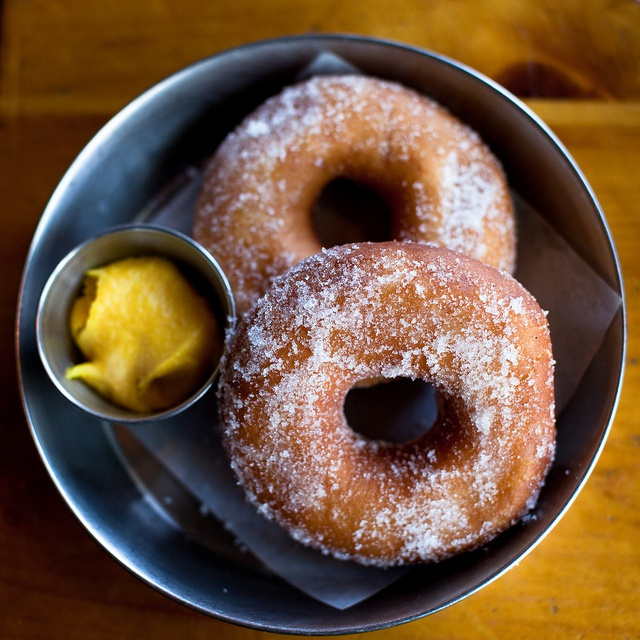Describe the objects in this image and their specific colors. I can see bowl in black, maroon, lavender, and lightpink tones, donut in black, lavender, brown, and lightpink tones, dining table in black, olive, maroon, and orange tones, and donut in black, tan, gray, and lightgray tones in this image. 